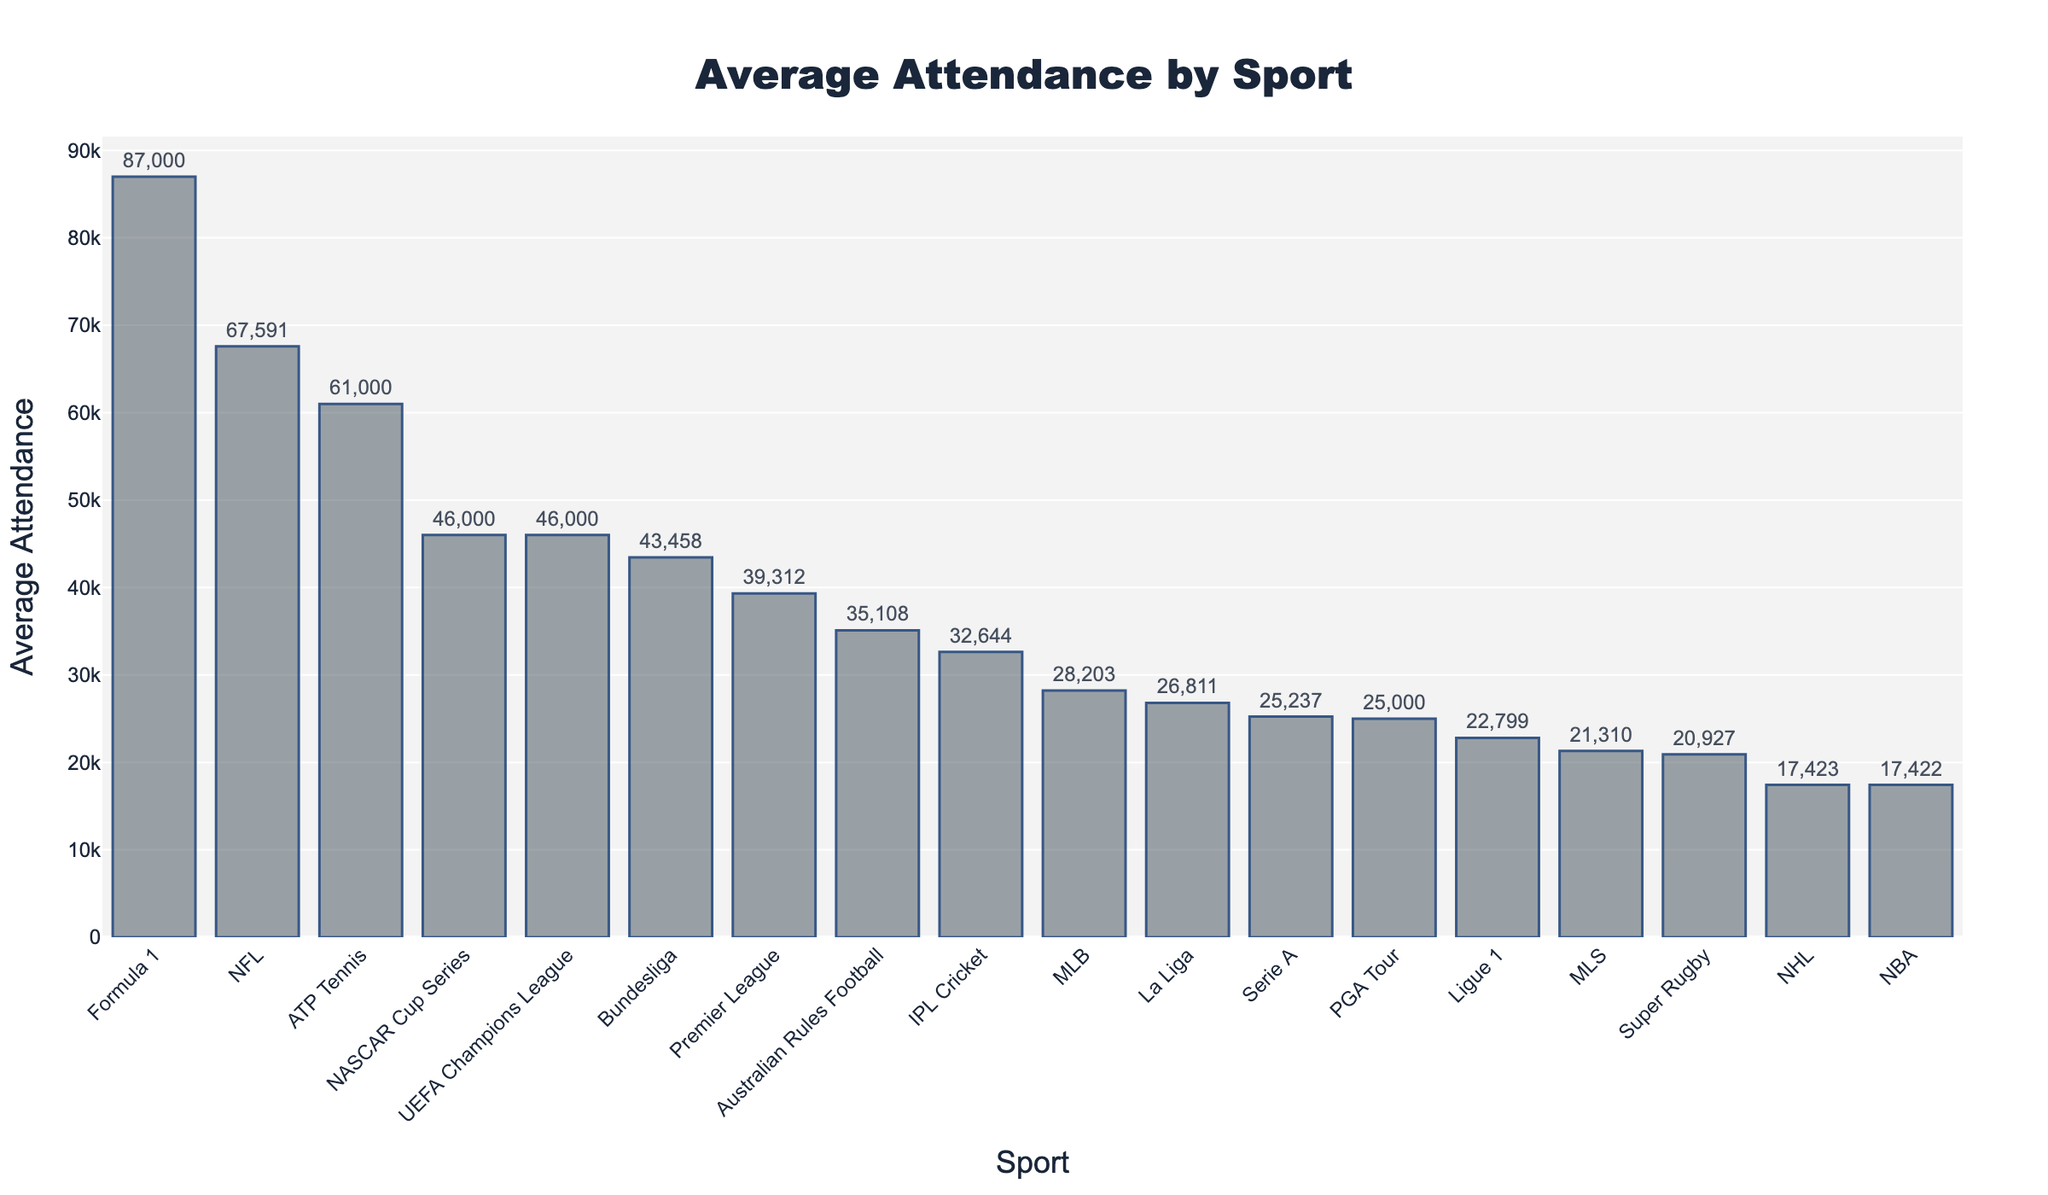What's the sport with the highest average attendance? By observing the plot, the tallest bar represents the sport with the highest average attendance. According to the data, this sport is Formula 1, with an average attendance of 87,000.
Answer: Formula 1 Which sport has the lowest average attendance, and what is that attendance? The bar with the shortest height indicates the sport with the lowest attendance. According to the data, Super Rugby has the lowest average attendance at 20,927.
Answer: Super Rugby, 20,927 Compare the average attendances of NFL and MLB. Which one is higher and by how much? To compare these two, we refer to their respective bar heights. NFL has an average attendance of 67,591, while MLB has 28,203. The difference is 67,591 - 28,203 = 39,388.
Answer: NFL by 39,388 What's the combined average attendance of NBA and NHL? NBA's average attendance is 17,422, and NHL's is 17,423. By adding these two, 17,422 + 17,423 = 34,845.
Answer: 34,845 Which sports have an average attendance of around 46,000? By looking at the bars near the 46,000 mark, NASCAR Cup Series and UEFA Champions League are close to this value. Both have average attendances of 46,000.
Answer: NASCAR Cup Series, UEFA Champions League Identify the sport with the third-highest attendance and its value. Observing the third tallest bar, UEFA Champions League comes in third with an average attendance of 46,000, after Formula 1 and NFL.
Answer: UEFA Champions League, 46,000 How does the average attendance of Bundesliga compare to Premier League? Bundesliga has an average attendance of 43,458, while Premier League has 39,312. By comparing these, Bundesliga has a higher attendance by 43,458 - 39,312 = 4,146.
Answer: Bundesliga by 4,146 Aggregate the average attendances of all European football leagues listed and find the total. The European football leagues listed include Premier League (39,312), Bundesliga (43,458), La Liga (26,811), Serie A (25,237), and Ligue 1 (22,799). Adding these: 39,312 + 43,458 + 26,811 + 25,237 + 22,799 = 157,617.
Answer: 157,617 Which sport has an almost equal attendance to the NBA? Observing the bar lengths, NHL is almost equal to the NBA, with attendances of 17,423 and 17,422 respectively, differing by just 1.
Answer: NHL What is the average attendance of sports that have more than 30,000 and less than 50,000 attendees? From the data, the relevant sports are NFL (67,591), Australian Rules Football (35,108), IPL Cricket (32,644), and Formula 1 (87,000; excluded for being above 50,000). Summing their attendances: 35,108 + 32,644 = 67,752. Then, there are 2 sports, so the average is 67,752 / 2 = 33,876.
Answer: 33,876 